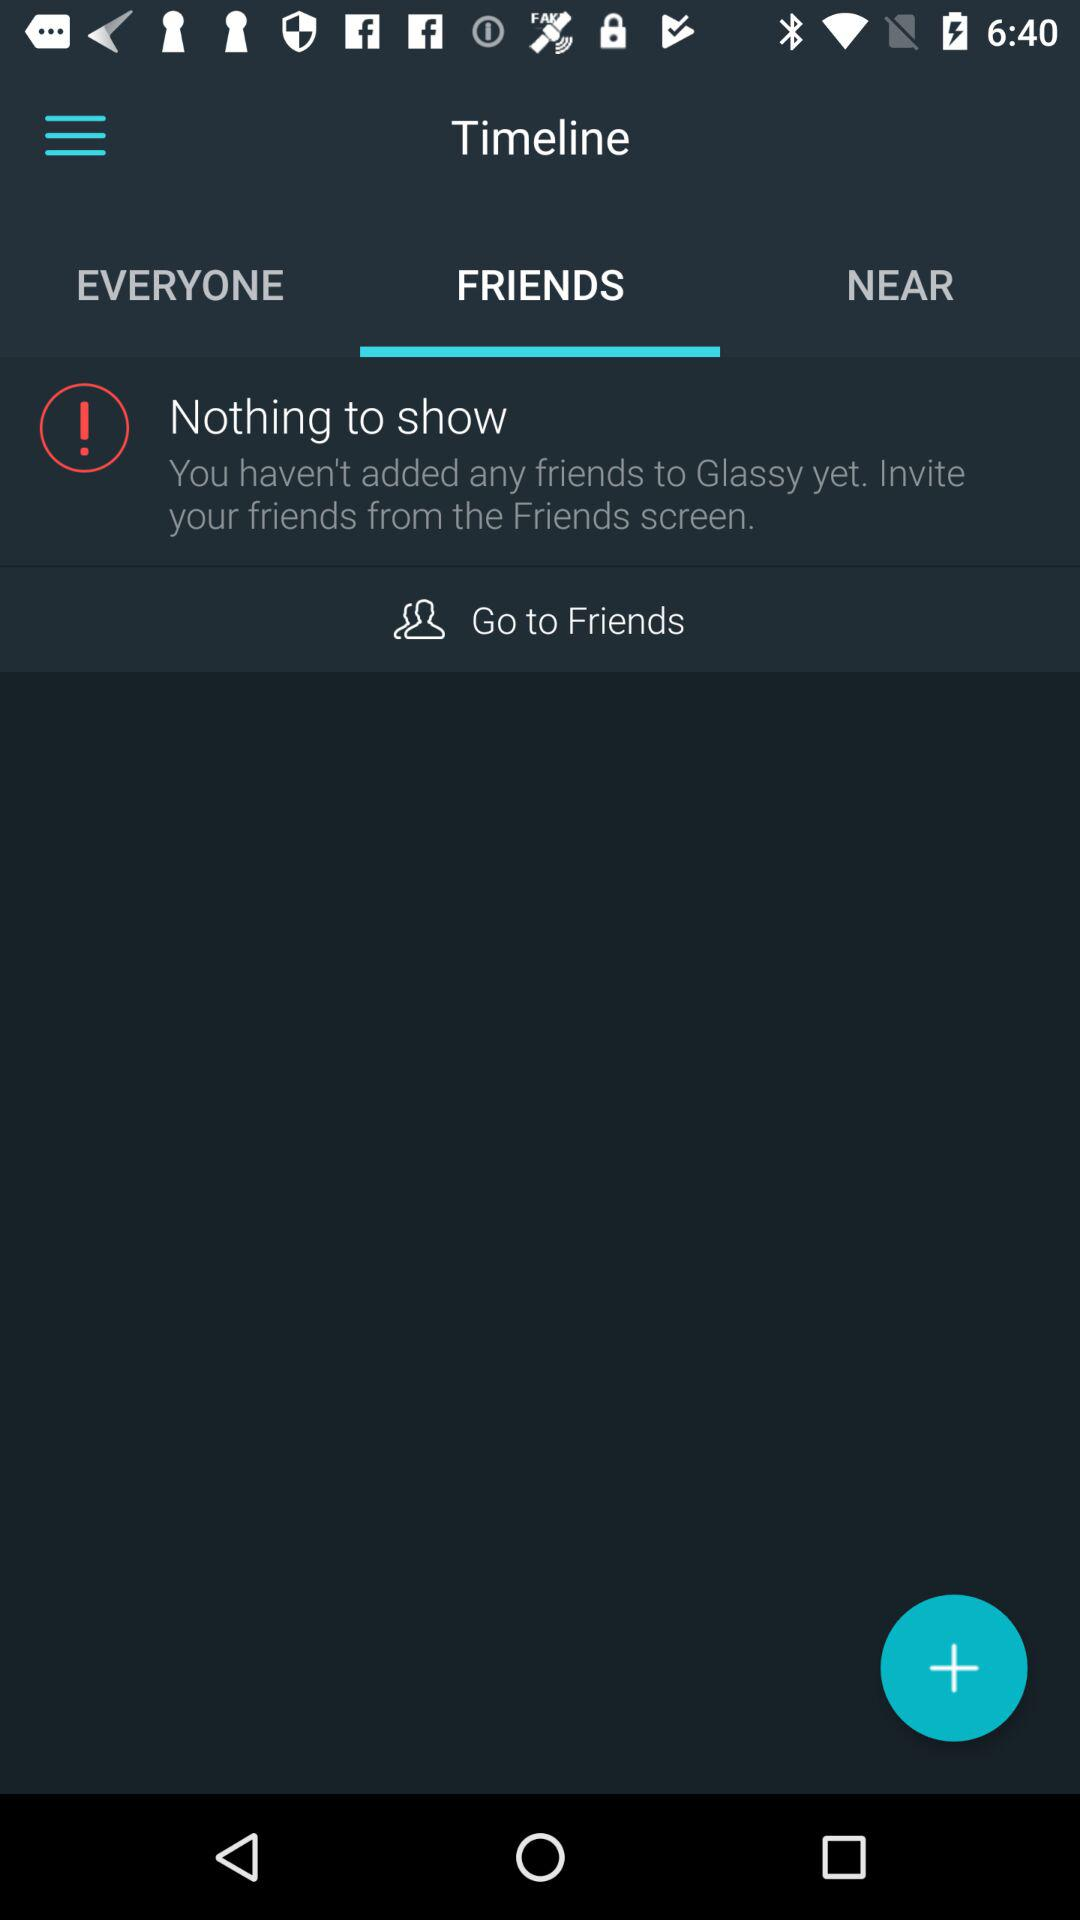Which option is selected in the "Timeline"? The selected option in the "Timeline" is "FRIENDS". 